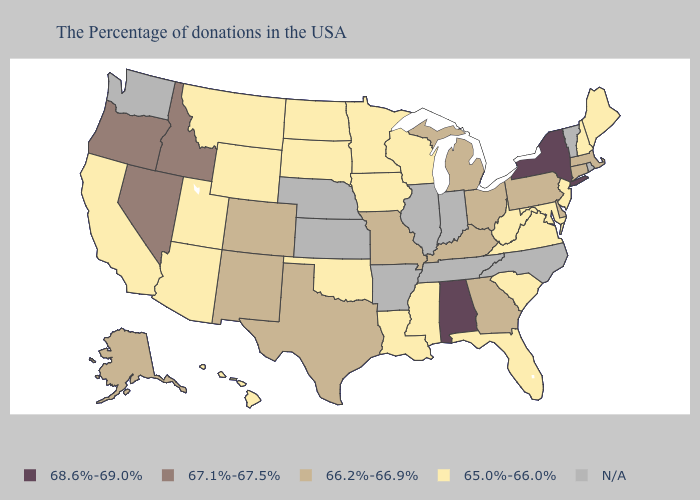What is the lowest value in the USA?
Be succinct. 65.0%-66.0%. Does Missouri have the lowest value in the MidWest?
Write a very short answer. No. Among the states that border Virginia , does Maryland have the lowest value?
Concise answer only. Yes. What is the value of Virginia?
Answer briefly. 65.0%-66.0%. How many symbols are there in the legend?
Concise answer only. 5. Does Idaho have the highest value in the USA?
Answer briefly. No. Does New Mexico have the lowest value in the USA?
Write a very short answer. No. Among the states that border South Carolina , which have the lowest value?
Keep it brief. Georgia. Among the states that border Pennsylvania , which have the lowest value?
Give a very brief answer. New Jersey, Maryland, West Virginia. What is the value of Texas?
Write a very short answer. 66.2%-66.9%. What is the value of Virginia?
Write a very short answer. 65.0%-66.0%. Name the states that have a value in the range 65.0%-66.0%?
Short answer required. Maine, New Hampshire, New Jersey, Maryland, Virginia, South Carolina, West Virginia, Florida, Wisconsin, Mississippi, Louisiana, Minnesota, Iowa, Oklahoma, South Dakota, North Dakota, Wyoming, Utah, Montana, Arizona, California, Hawaii. Is the legend a continuous bar?
Concise answer only. No. Name the states that have a value in the range 66.2%-66.9%?
Quick response, please. Massachusetts, Connecticut, Delaware, Pennsylvania, Ohio, Georgia, Michigan, Kentucky, Missouri, Texas, Colorado, New Mexico, Alaska. What is the value of Louisiana?
Short answer required. 65.0%-66.0%. 